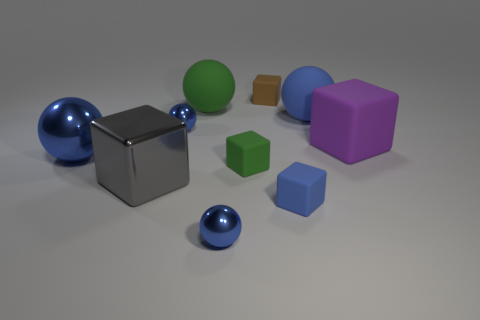Subtract all blue spheres. How many were subtracted if there are2blue spheres left? 2 Subtract all large balls. How many balls are left? 2 Subtract all blue blocks. How many yellow spheres are left? 0 Subtract all blue balls. Subtract all big matte blocks. How many objects are left? 5 Add 5 small green cubes. How many small green cubes are left? 6 Add 5 red metallic balls. How many red metallic balls exist? 5 Subtract all green cubes. How many cubes are left? 4 Subtract 4 blue balls. How many objects are left? 6 Subtract 3 blocks. How many blocks are left? 2 Subtract all red spheres. Subtract all cyan blocks. How many spheres are left? 5 